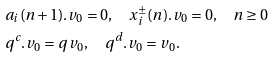Convert formula to latex. <formula><loc_0><loc_0><loc_500><loc_500>& a _ { i } ( n + 1 ) . v _ { 0 } = 0 , \quad x ^ { \pm } _ { i } ( n ) . v _ { 0 } = 0 , \quad n \geq 0 \\ & q ^ { c } . v _ { 0 } = q v _ { 0 } , \quad q ^ { d } . v _ { 0 } = v _ { 0 } .</formula> 